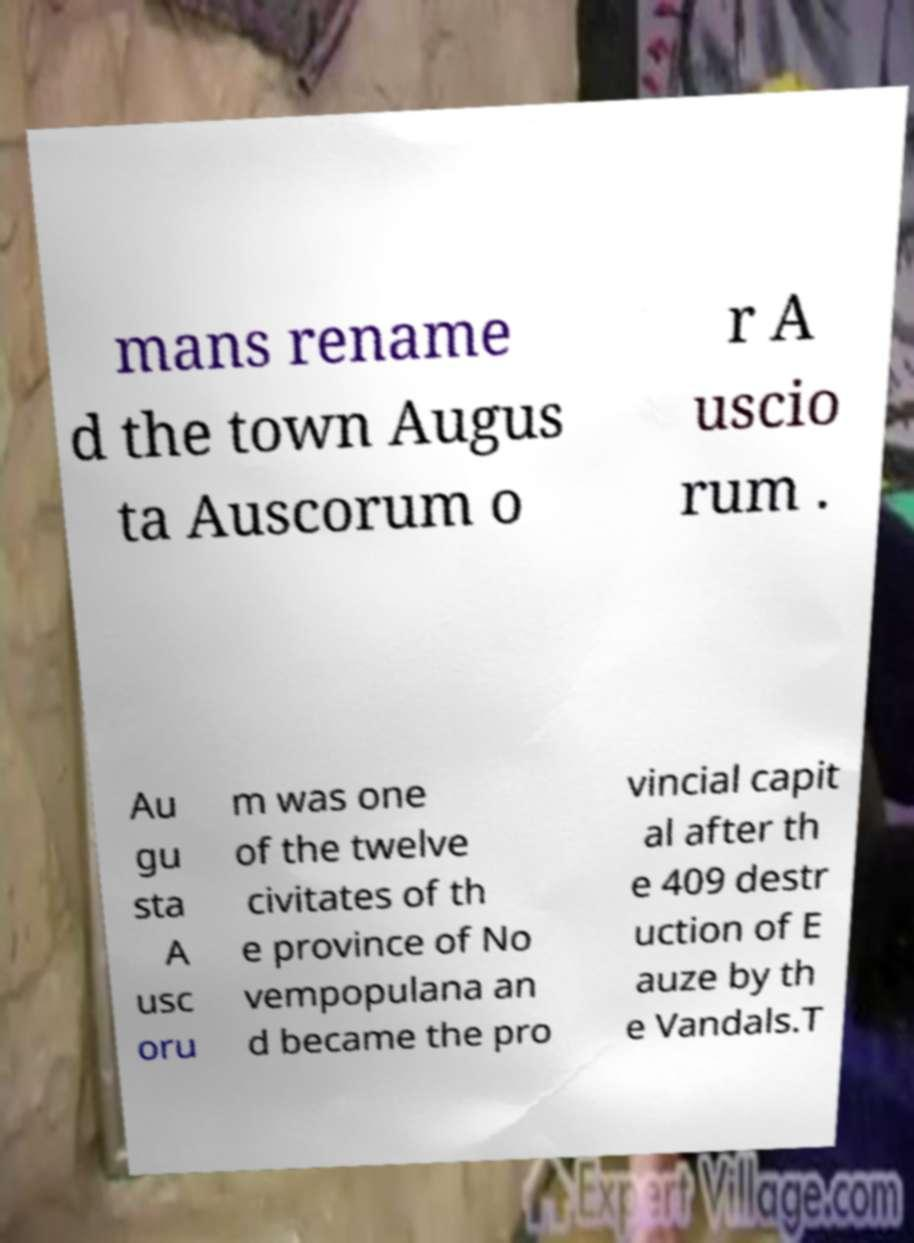I need the written content from this picture converted into text. Can you do that? mans rename d the town Augus ta Auscorum o r A uscio rum . Au gu sta A usc oru m was one of the twelve civitates of th e province of No vempopulana an d became the pro vincial capit al after th e 409 destr uction of E auze by th e Vandals.T 